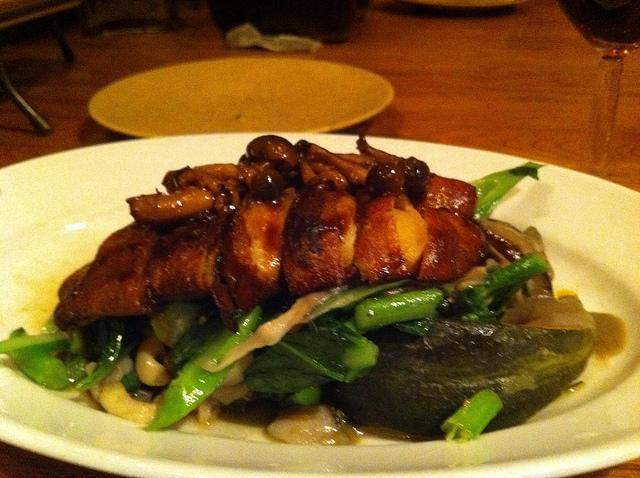What has caused the food on the plate to look shiny?
Indicate the correct choice and explain in the format: 'Answer: answer
Rationale: rationale.'
Options: Air, sauce, glare, soda. Answer: sauce.
Rationale: The plate is covered in sauce. 